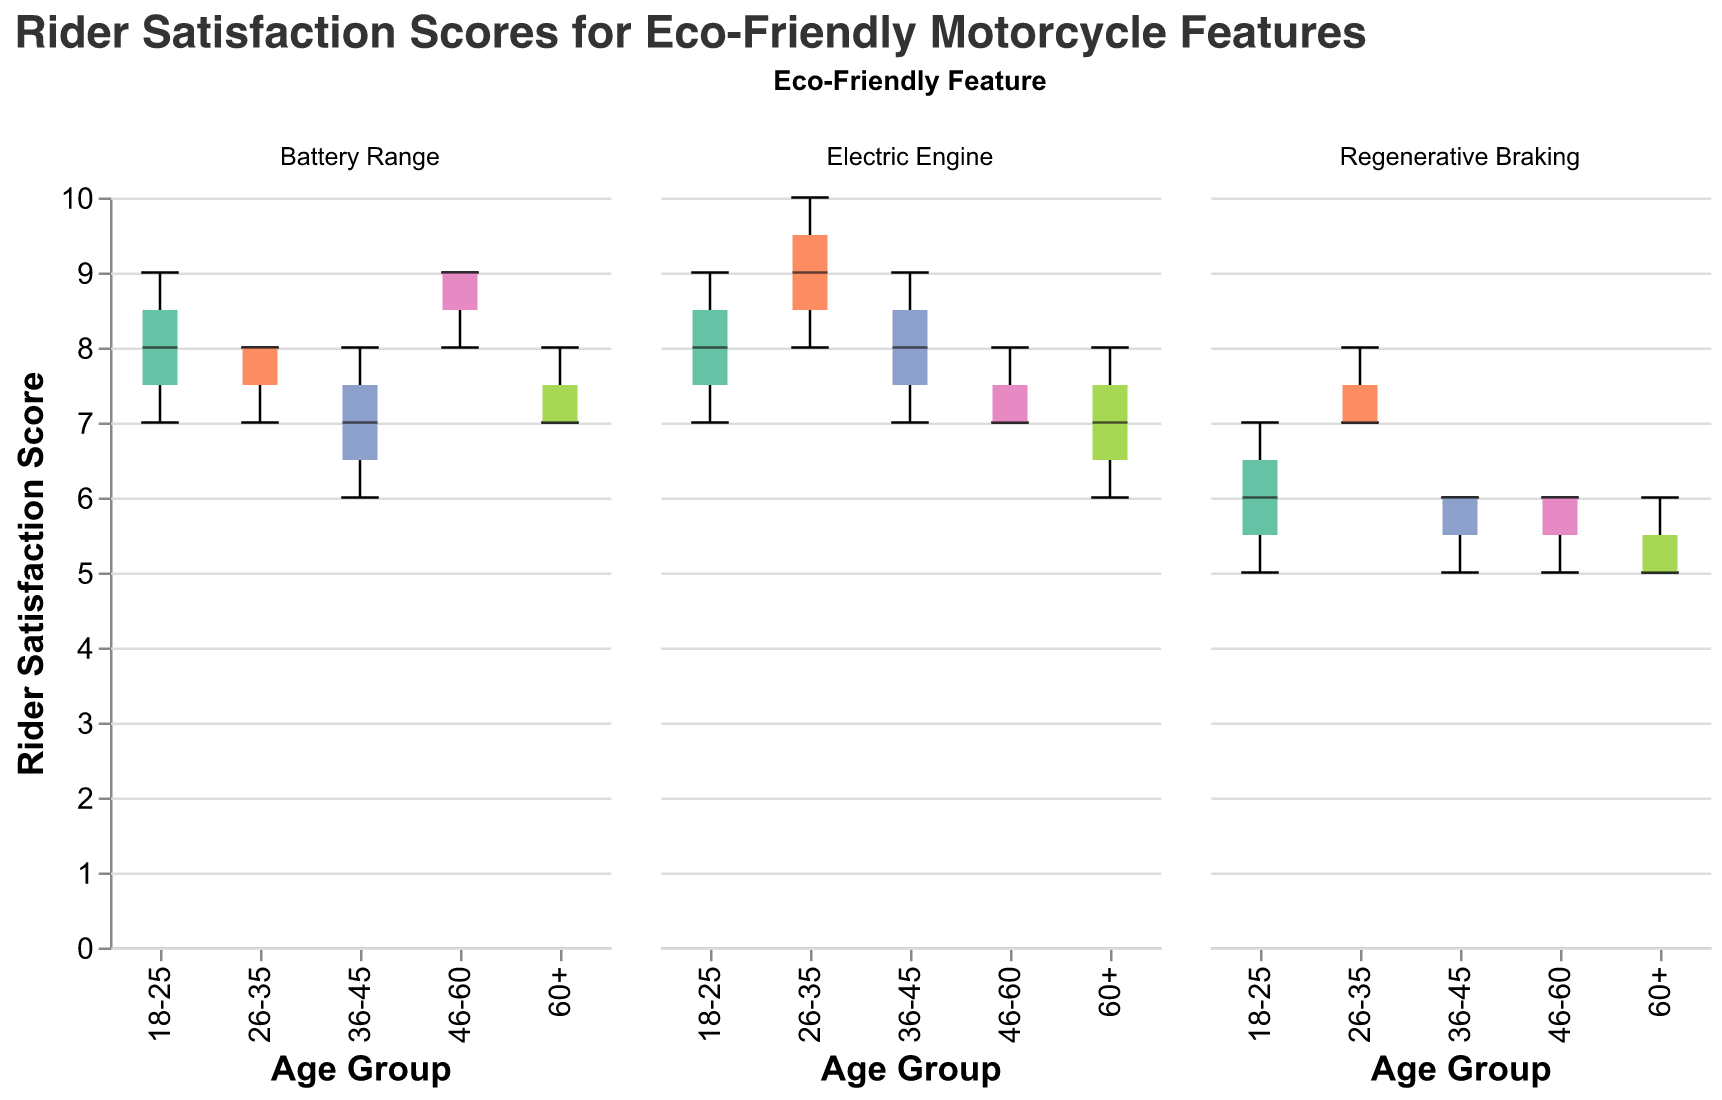What is the title of the figure? The title of the figure is prominently displayed at the top and provides a summary of what the figure shows.
Answer: Rider Satisfaction Scores for Eco-Friendly Motorcycle Features Which age group has the highest median rider satisfaction score for the electric engine feature? By observing the median lines within the box plots for the electric engine feature, we can compare the positions to determine the highest median. The age group 26-35 has the highest median score.
Answer: 26-35 What is the range of rider satisfaction scores for the regenerative braking feature in the 36-45 age group? The range of a box plot is shown from the minimum to the maximum value. For the 36-45 age group in the regenerative braking feature, the scores range from 5 to 6.
Answer: 5 to 6 How does the median rider satisfaction score for the battery range feature in the 46-60 age group compare to the 18-25 age group? The median for the 46-60 age group is higher than the median for the 18-25 age group for the battery range feature. This is observed by comparing the median lines in the respective box plots.
Answer: Higher Which eco-friendly feature has the lowest median rider satisfaction score for the 60+ age group? By examining the three box plots for the 60+ age group, we can identify that regenerative braking has the lowest median rider satisfaction score.
Answer: Regenerative Braking Which feature shows the most consistent rider satisfaction across all age groups? Consistency in a box plot can be gauged by the narrowness of the boxes, indicating less variability. The battery range feature shows the narrowest range across most age groups, indicating consistent satisfaction.
Answer: Battery Range What is the median rider satisfaction score for regenerative braking in the 26-35 age group? Locate the median line within the box plot for the 26-35 age group under the regenerative braking feature. The median score is 7.
Answer: 7 Between which age groups is the range of rider satisfaction scores for the electric engine feature the largest? Compare the ranges (min to max) of the electric engine feature's box plots. The age group 26-35 has the widest range reaching from 8 to 10, while 60+ spans from 6 to 8. The largest range comparison is between 26-35 and 60+.
Answer: 26-35 and 60+ Which age group has the smallest interquartile range for the battery range feature? The interquartile range (IQR) is the distance between the first and third quartiles (the edges of the box). The age group 26-35 for the battery range feature has the smallest IQR, indicating less variability within this group.
Answer: 26-35 